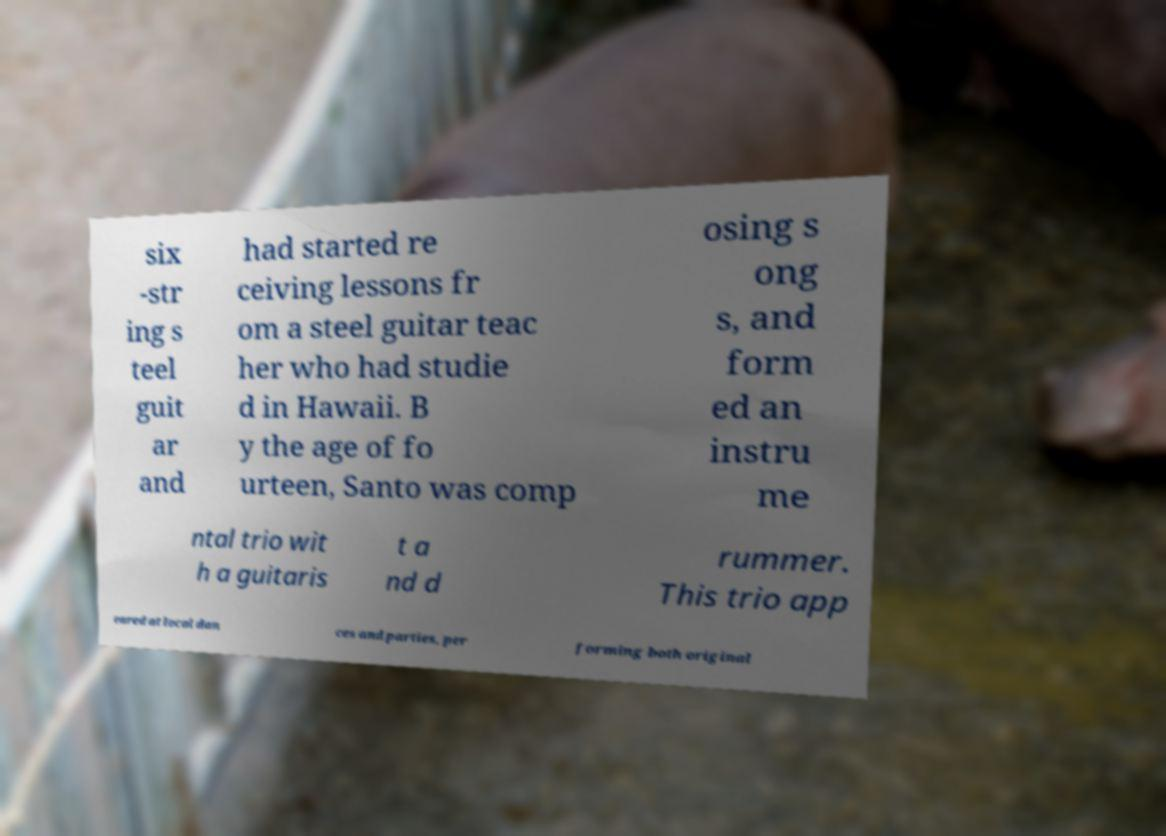I need the written content from this picture converted into text. Can you do that? six -str ing s teel guit ar and had started re ceiving lessons fr om a steel guitar teac her who had studie d in Hawaii. B y the age of fo urteen, Santo was comp osing s ong s, and form ed an instru me ntal trio wit h a guitaris t a nd d rummer. This trio app eared at local dan ces and parties, per forming both original 